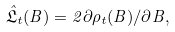<formula> <loc_0><loc_0><loc_500><loc_500>\hat { \mathfrak { L } } _ { t } ( B ) = 2 \partial \rho _ { t } ( B ) / \partial B ,</formula> 